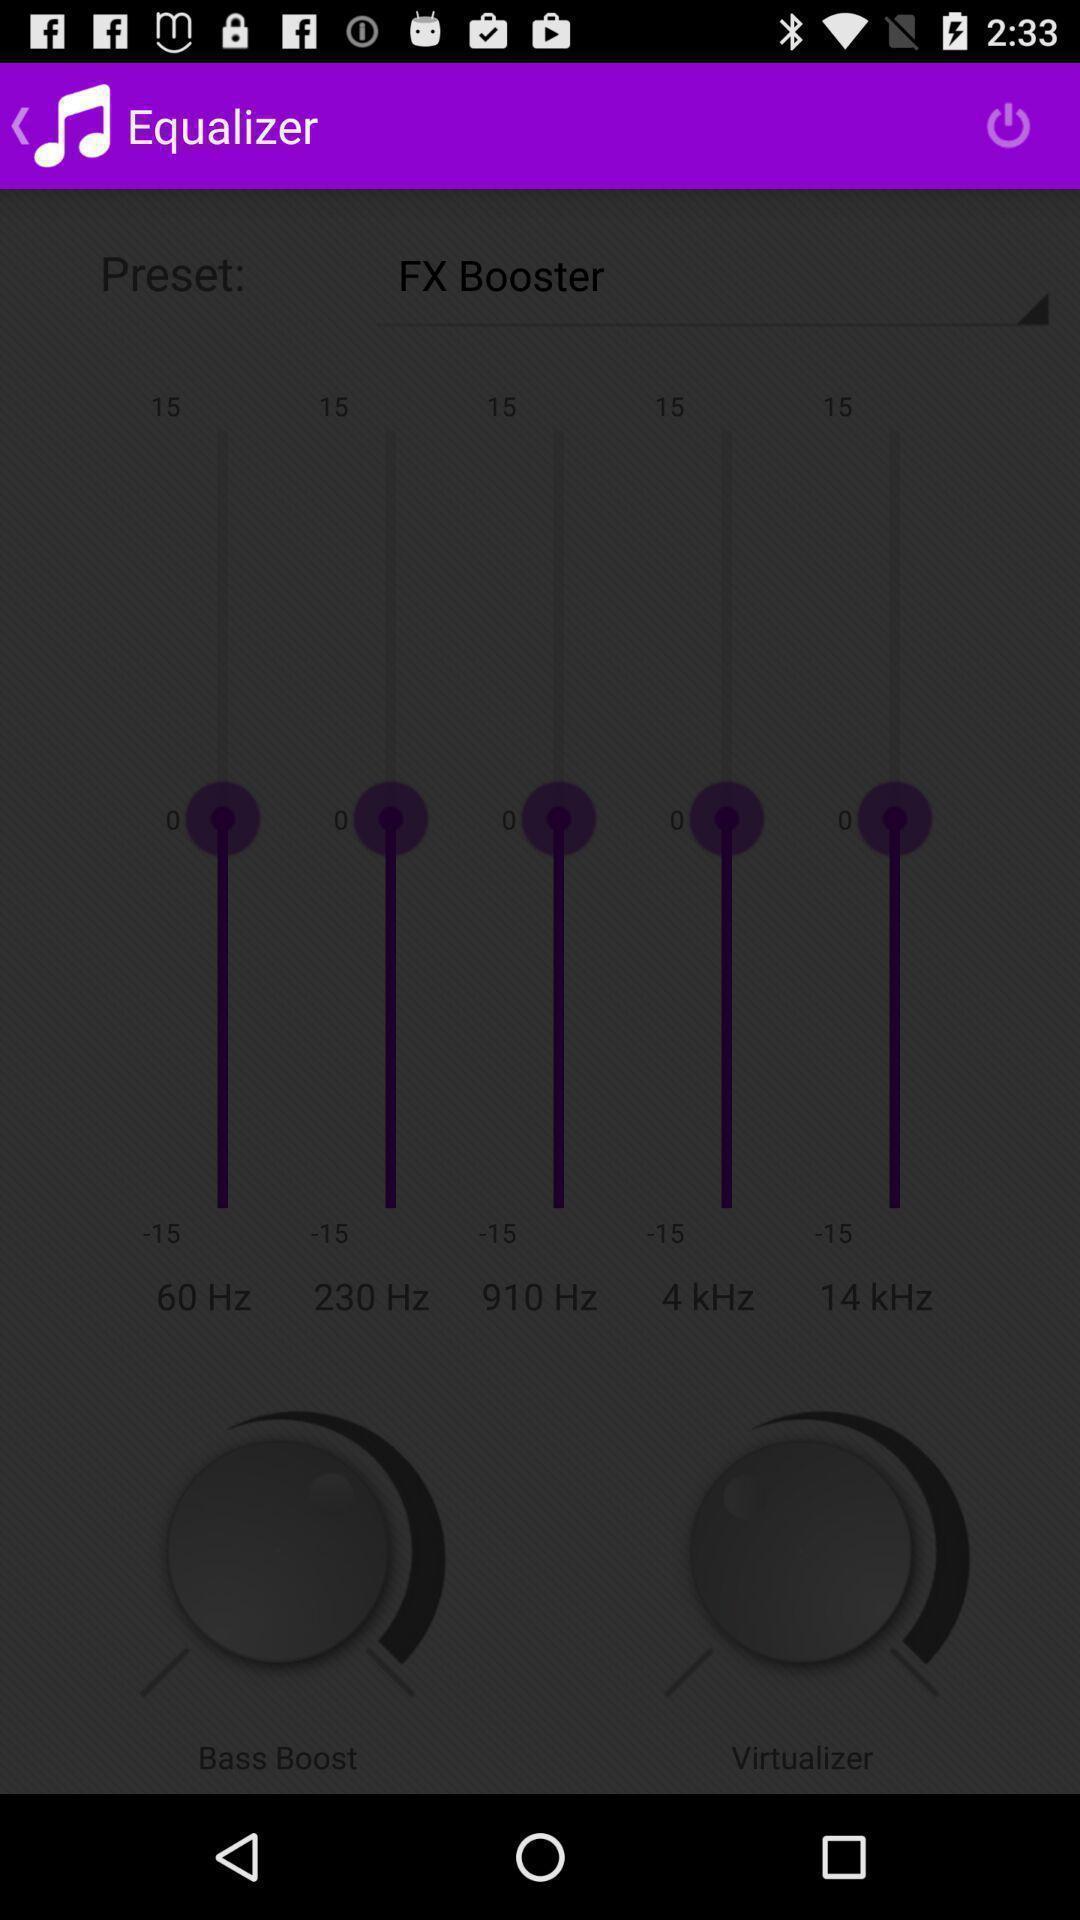Provide a textual representation of this image. Screen displaying equalizer page. 